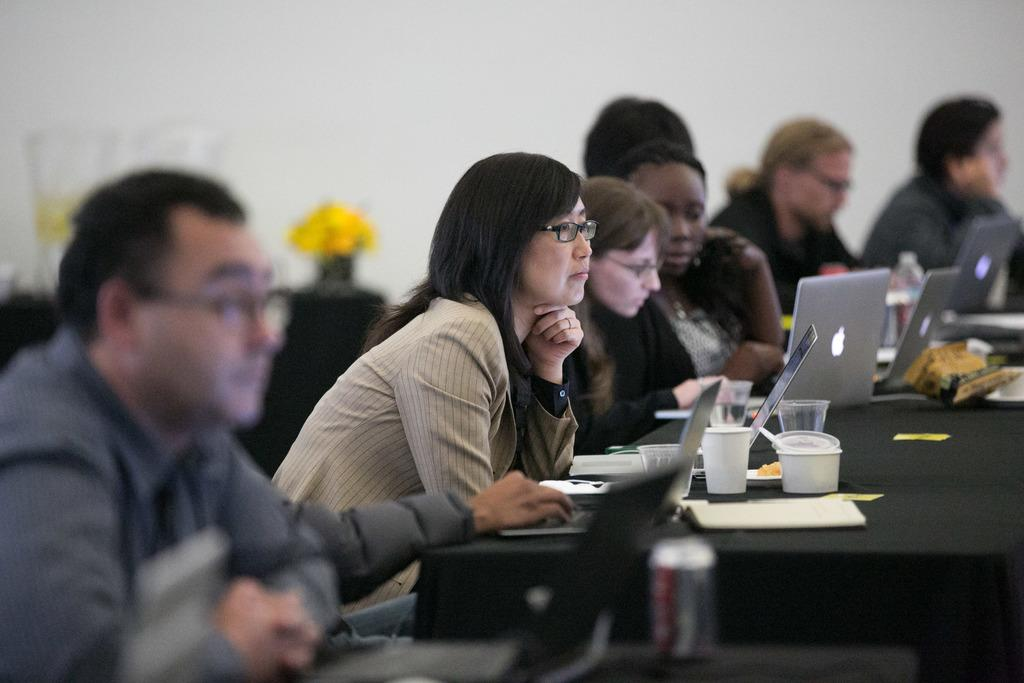What are the people in the image doing? The people in the image are sitting and looking at systems. What objects can be seen on the table in the image? There is a water glass and a can on the table in the image. What is visible in the background of the image? There is a plant in the background of the image. What type of paper is being crushed by the people in the image? There is no paper being crushed in the image; the people are looking at systems. What color is the copper object on the table in the image? There is no copper object present in the image. 